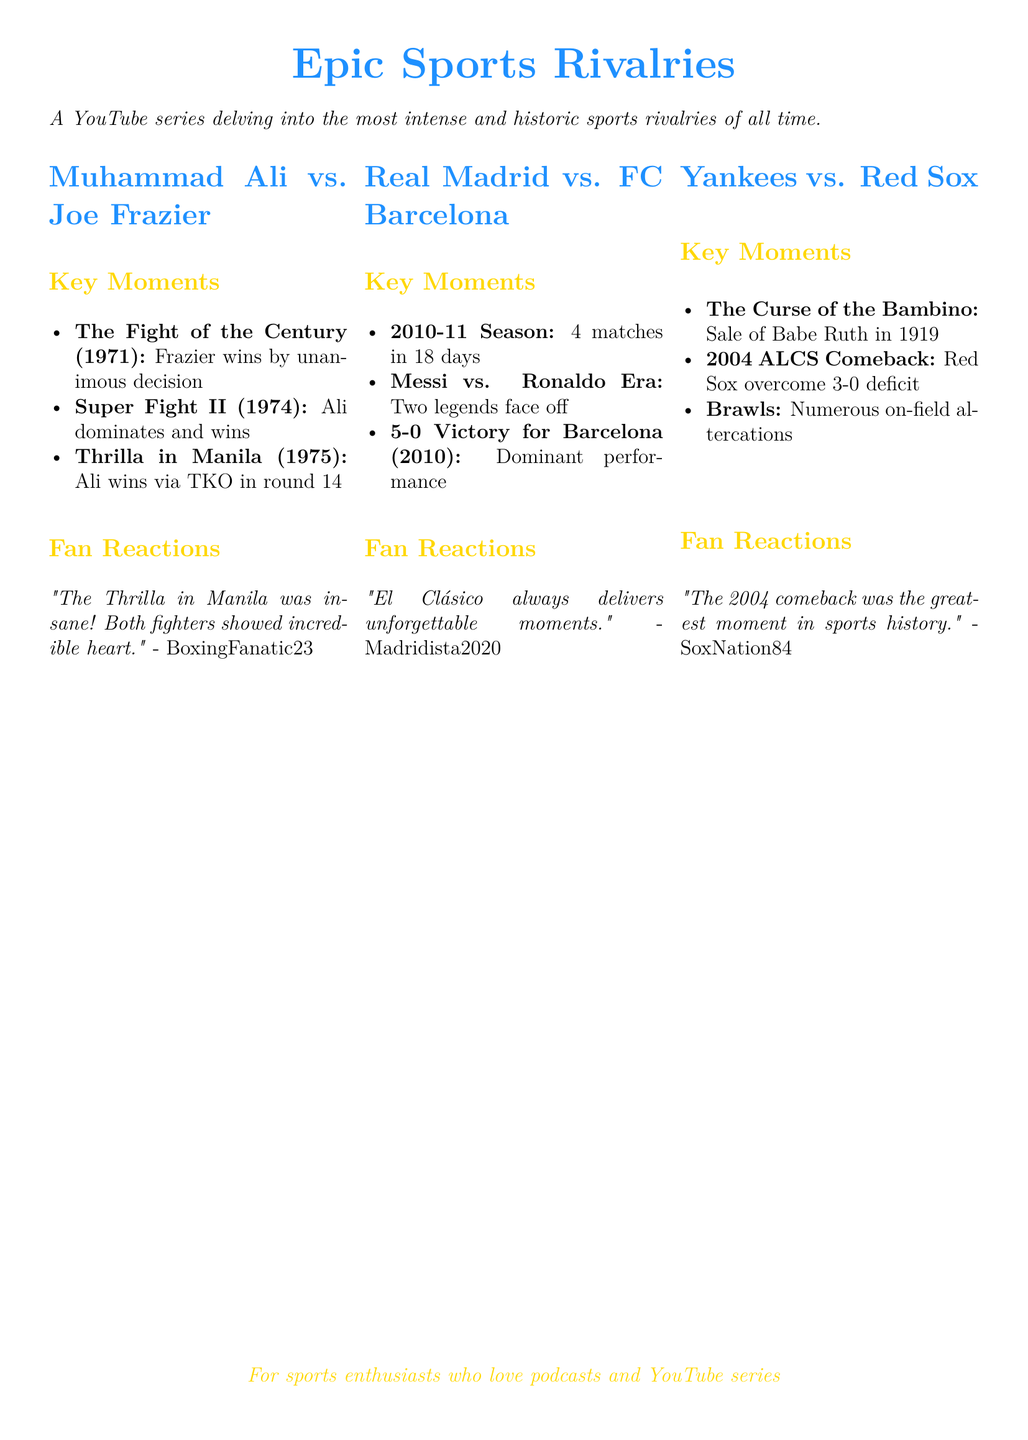What was the outcome of the Fight of the Century? The Fight of the Century took place in 1971, and Frazier won by unanimous decision.
Answer: Frazier by unanimous decision Which season featured 4 matches in 18 days between Real Madrid and FC Barcelona? The document mentions the 2010-11 season as the period when the two teams had 4 matches in 18 days.
Answer: 2010-11 Season What is the key moment associated with Babe Ruth in the Yankees vs. Red Sox rivalry? The document states that the sale of Babe Ruth in 1919 is crucial to the rivalry, referred to as the Curse of the Bambino.
Answer: The Curse of the Bambino Who had a greater impact on the Real Madrid vs. FC Barcelona rivalry during their era? The document highlights that Lionel Messi and Cristiano Ronaldo faced off during the Messi vs. Ronaldo Era.
Answer: Messi vs. Ronaldo What was the fan reaction to Thrilla in Manila? The fan reaction comments on the fight, stating both fighters showed incredible heart during the Thrilla in Manila.
Answer: Incredible heart Which rivalry is associated with a comeback from a 3-0 deficit? The Yankees vs. Red Sox rivalry is noted for the 2004 ALCS comeback where the Red Sox overcame a 3-0 deficit.
Answer: Yankees vs. Red Sox What was the fan's opinion on El Clásico? A fan expressed that El Clásico always delivers unforgettable moments.
Answer: Unforgettable moments In which year did Barcelona achieve a 5-0 victory over Real Madrid? The document indicates that Barcelona achieved this victory in 2010.
Answer: 2010 